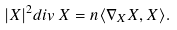Convert formula to latex. <formula><loc_0><loc_0><loc_500><loc_500>| X | ^ { 2 } d i v \, X = n \langle \nabla _ { X } X , X \rangle .</formula> 